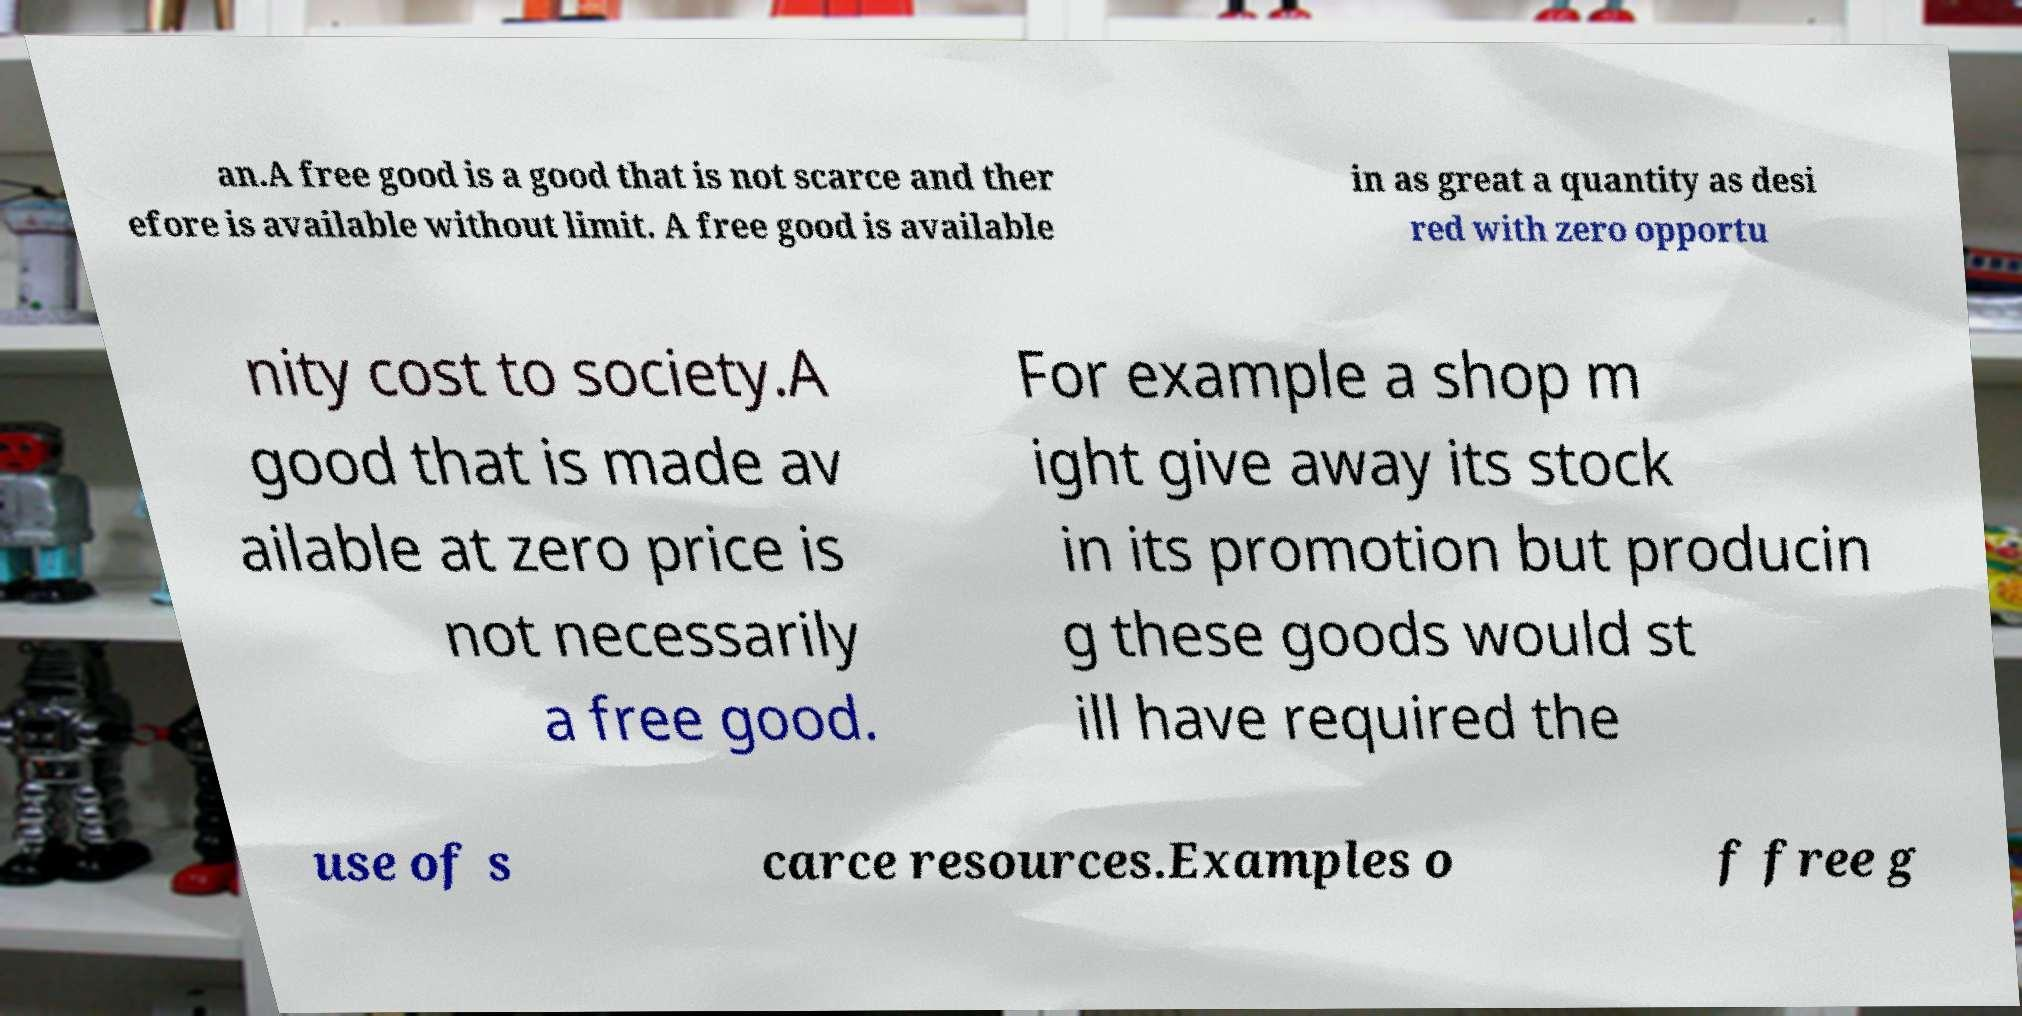Please identify and transcribe the text found in this image. an.A free good is a good that is not scarce and ther efore is available without limit. A free good is available in as great a quantity as desi red with zero opportu nity cost to society.A good that is made av ailable at zero price is not necessarily a free good. For example a shop m ight give away its stock in its promotion but producin g these goods would st ill have required the use of s carce resources.Examples o f free g 